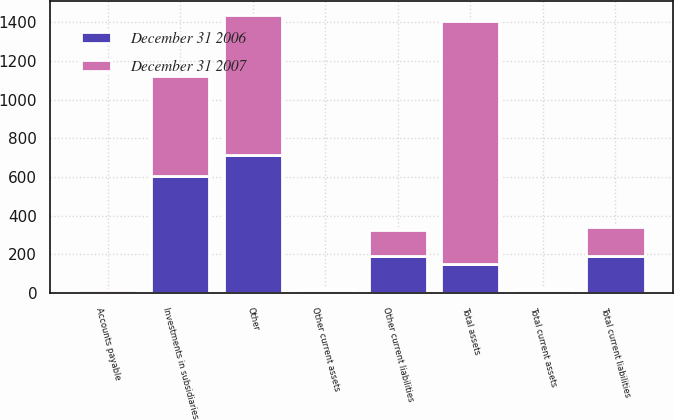<chart> <loc_0><loc_0><loc_500><loc_500><stacked_bar_chart><ecel><fcel>Other current assets<fcel>Total current assets<fcel>Investments in subsidiaries<fcel>Other<fcel>Total assets<fcel>Accounts payable<fcel>Other current liabilities<fcel>Total current liabilities<nl><fcel>December 31 2006<fcel>16<fcel>16<fcel>606<fcel>712<fcel>151<fcel>1<fcel>190<fcel>191<nl><fcel>December 31 2007<fcel>12<fcel>12<fcel>517<fcel>724<fcel>1253<fcel>14<fcel>137<fcel>151<nl></chart> 